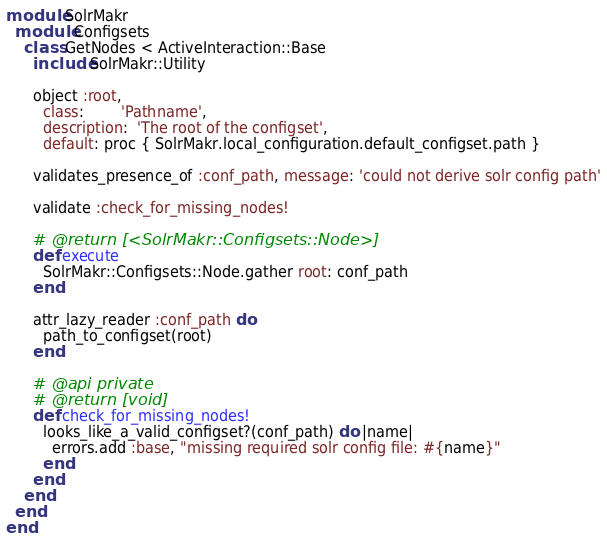<code> <loc_0><loc_0><loc_500><loc_500><_Ruby_>module SolrMakr
  module Configsets
    class GetNodes < ActiveInteraction::Base
      include SolrMakr::Utility

      object :root,
        class:        'Pathname',
        description:  'The root of the configset',
        default: proc { SolrMakr.local_configuration.default_configset.path }

      validates_presence_of :conf_path, message: 'could not derive solr config path'

      validate :check_for_missing_nodes!

      # @return [<SolrMakr::Configsets::Node>]
      def execute
        SolrMakr::Configsets::Node.gather root: conf_path
      end

      attr_lazy_reader :conf_path do
        path_to_configset(root)
      end

      # @api private
      # @return [void]
      def check_for_missing_nodes!
        looks_like_a_valid_configset?(conf_path) do |name|
          errors.add :base, "missing required solr config file: #{name}"
        end
      end
    end
  end
end
</code> 